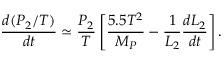<formula> <loc_0><loc_0><loc_500><loc_500>{ \frac { d ( P _ { 2 } / T ) } { d t } } \simeq { \frac { P _ { 2 } } { T } } \left [ { \frac { 5 . 5 T ^ { 2 } } { M _ { P } } } - { \frac { 1 } { L _ { 2 } } } { \frac { d L _ { 2 } } { d t } } \right ] .</formula> 